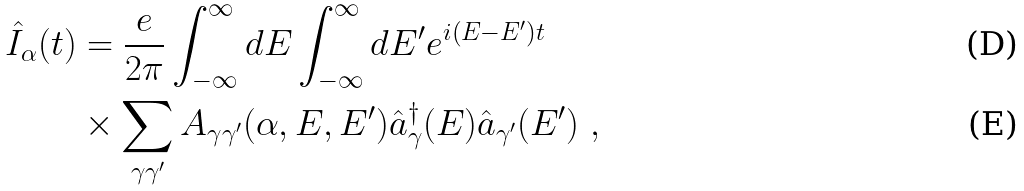<formula> <loc_0><loc_0><loc_500><loc_500>\hat { I } _ { \alpha } ( t ) & = \frac { e } { 2 \pi } \int _ { - \infty } ^ { \infty } d E \int _ { - \infty } ^ { \infty } d E ^ { \prime } e ^ { i ( E - E ^ { \prime } ) t } \\ & \times \sum _ { \gamma \gamma ^ { \prime } } A _ { \gamma \gamma ^ { \prime } } ( \alpha , E , E ^ { \prime } ) \hat { a } ^ { \dagger } _ { \gamma } ( E ) \hat { a } _ { \gamma ^ { \prime } } ( E ^ { \prime } ) \ ,</formula> 